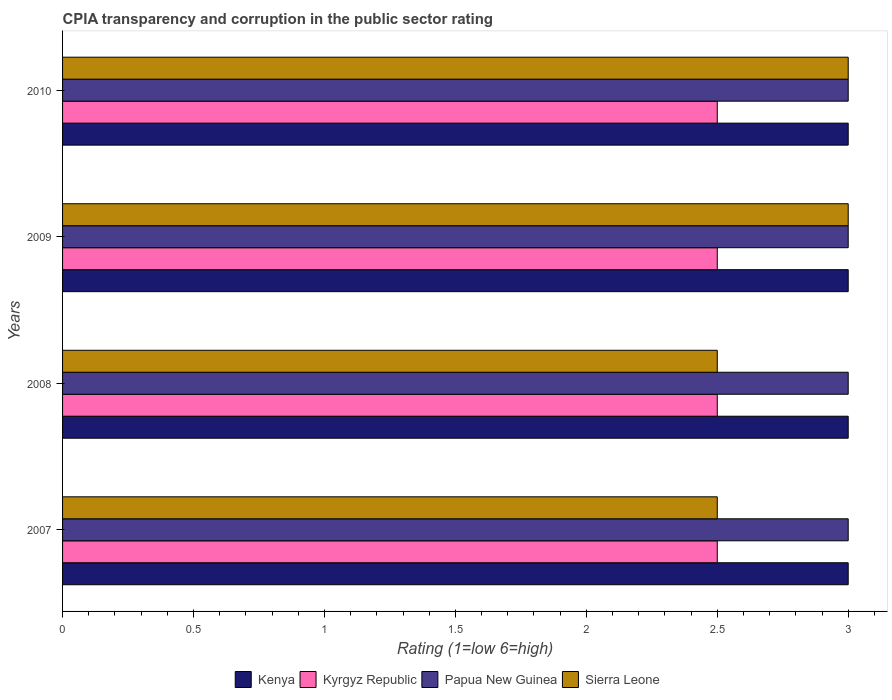Are the number of bars on each tick of the Y-axis equal?
Your response must be concise. Yes. How many bars are there on the 3rd tick from the top?
Ensure brevity in your answer.  4. How many bars are there on the 4th tick from the bottom?
Provide a short and direct response. 4. What is the CPIA rating in Kyrgyz Republic in 2008?
Keep it short and to the point. 2.5. Across all years, what is the maximum CPIA rating in Kenya?
Your response must be concise. 3. Across all years, what is the minimum CPIA rating in Papua New Guinea?
Offer a terse response. 3. In which year was the CPIA rating in Sierra Leone maximum?
Your response must be concise. 2009. In which year was the CPIA rating in Sierra Leone minimum?
Offer a very short reply. 2007. What is the difference between the CPIA rating in Sierra Leone in 2007 and that in 2010?
Provide a succinct answer. -0.5. Is the difference between the CPIA rating in Kenya in 2008 and 2010 greater than the difference between the CPIA rating in Kyrgyz Republic in 2008 and 2010?
Your answer should be very brief. No. What is the difference between the highest and the second highest CPIA rating in Kenya?
Give a very brief answer. 0. What does the 3rd bar from the top in 2009 represents?
Provide a short and direct response. Kyrgyz Republic. What does the 4th bar from the bottom in 2007 represents?
Give a very brief answer. Sierra Leone. How many bars are there?
Your answer should be compact. 16. What is the difference between two consecutive major ticks on the X-axis?
Give a very brief answer. 0.5. Does the graph contain any zero values?
Ensure brevity in your answer.  No. Where does the legend appear in the graph?
Ensure brevity in your answer.  Bottom center. How many legend labels are there?
Make the answer very short. 4. What is the title of the graph?
Your response must be concise. CPIA transparency and corruption in the public sector rating. Does "Ghana" appear as one of the legend labels in the graph?
Provide a succinct answer. No. What is the label or title of the Y-axis?
Your answer should be very brief. Years. What is the Rating (1=low 6=high) of Kenya in 2007?
Keep it short and to the point. 3. What is the Rating (1=low 6=high) in Papua New Guinea in 2007?
Give a very brief answer. 3. What is the Rating (1=low 6=high) in Kenya in 2008?
Give a very brief answer. 3. What is the Rating (1=low 6=high) in Sierra Leone in 2008?
Give a very brief answer. 2.5. What is the Rating (1=low 6=high) of Kyrgyz Republic in 2009?
Offer a terse response. 2.5. What is the Rating (1=low 6=high) of Papua New Guinea in 2009?
Keep it short and to the point. 3. What is the Rating (1=low 6=high) in Kenya in 2010?
Your response must be concise. 3. What is the Rating (1=low 6=high) of Kyrgyz Republic in 2010?
Ensure brevity in your answer.  2.5. What is the Rating (1=low 6=high) of Papua New Guinea in 2010?
Your response must be concise. 3. Across all years, what is the maximum Rating (1=low 6=high) of Papua New Guinea?
Offer a terse response. 3. Across all years, what is the maximum Rating (1=low 6=high) in Sierra Leone?
Make the answer very short. 3. Across all years, what is the minimum Rating (1=low 6=high) in Papua New Guinea?
Your answer should be very brief. 3. Across all years, what is the minimum Rating (1=low 6=high) of Sierra Leone?
Offer a terse response. 2.5. What is the total Rating (1=low 6=high) in Kenya in the graph?
Your answer should be very brief. 12. What is the total Rating (1=low 6=high) in Sierra Leone in the graph?
Offer a very short reply. 11. What is the difference between the Rating (1=low 6=high) of Kyrgyz Republic in 2007 and that in 2008?
Ensure brevity in your answer.  0. What is the difference between the Rating (1=low 6=high) in Papua New Guinea in 2007 and that in 2008?
Offer a terse response. 0. What is the difference between the Rating (1=low 6=high) of Sierra Leone in 2007 and that in 2008?
Your answer should be compact. 0. What is the difference between the Rating (1=low 6=high) of Kyrgyz Republic in 2007 and that in 2009?
Provide a short and direct response. 0. What is the difference between the Rating (1=low 6=high) in Kenya in 2007 and that in 2010?
Provide a short and direct response. 0. What is the difference between the Rating (1=low 6=high) of Papua New Guinea in 2007 and that in 2010?
Ensure brevity in your answer.  0. What is the difference between the Rating (1=low 6=high) of Sierra Leone in 2007 and that in 2010?
Make the answer very short. -0.5. What is the difference between the Rating (1=low 6=high) of Kenya in 2008 and that in 2009?
Give a very brief answer. 0. What is the difference between the Rating (1=low 6=high) of Papua New Guinea in 2008 and that in 2009?
Your answer should be compact. 0. What is the difference between the Rating (1=low 6=high) of Sierra Leone in 2008 and that in 2009?
Offer a terse response. -0.5. What is the difference between the Rating (1=low 6=high) in Kenya in 2009 and that in 2010?
Provide a succinct answer. 0. What is the difference between the Rating (1=low 6=high) of Papua New Guinea in 2009 and that in 2010?
Provide a short and direct response. 0. What is the difference between the Rating (1=low 6=high) of Sierra Leone in 2009 and that in 2010?
Your response must be concise. 0. What is the difference between the Rating (1=low 6=high) of Kenya in 2007 and the Rating (1=low 6=high) of Papua New Guinea in 2008?
Offer a terse response. 0. What is the difference between the Rating (1=low 6=high) of Kenya in 2007 and the Rating (1=low 6=high) of Sierra Leone in 2008?
Offer a terse response. 0.5. What is the difference between the Rating (1=low 6=high) in Kyrgyz Republic in 2007 and the Rating (1=low 6=high) in Sierra Leone in 2008?
Offer a very short reply. 0. What is the difference between the Rating (1=low 6=high) of Papua New Guinea in 2007 and the Rating (1=low 6=high) of Sierra Leone in 2008?
Your response must be concise. 0.5. What is the difference between the Rating (1=low 6=high) in Kenya in 2007 and the Rating (1=low 6=high) in Kyrgyz Republic in 2009?
Your answer should be very brief. 0.5. What is the difference between the Rating (1=low 6=high) in Kenya in 2007 and the Rating (1=low 6=high) in Papua New Guinea in 2009?
Your response must be concise. 0. What is the difference between the Rating (1=low 6=high) in Kenya in 2007 and the Rating (1=low 6=high) in Sierra Leone in 2009?
Give a very brief answer. 0. What is the difference between the Rating (1=low 6=high) in Kyrgyz Republic in 2007 and the Rating (1=low 6=high) in Papua New Guinea in 2009?
Give a very brief answer. -0.5. What is the difference between the Rating (1=low 6=high) in Kyrgyz Republic in 2007 and the Rating (1=low 6=high) in Sierra Leone in 2009?
Ensure brevity in your answer.  -0.5. What is the difference between the Rating (1=low 6=high) of Kenya in 2007 and the Rating (1=low 6=high) of Kyrgyz Republic in 2010?
Provide a short and direct response. 0.5. What is the difference between the Rating (1=low 6=high) of Kenya in 2007 and the Rating (1=low 6=high) of Sierra Leone in 2010?
Your answer should be compact. 0. What is the difference between the Rating (1=low 6=high) in Papua New Guinea in 2007 and the Rating (1=low 6=high) in Sierra Leone in 2010?
Ensure brevity in your answer.  0. What is the difference between the Rating (1=low 6=high) in Kenya in 2008 and the Rating (1=low 6=high) in Kyrgyz Republic in 2009?
Give a very brief answer. 0.5. What is the difference between the Rating (1=low 6=high) of Kenya in 2008 and the Rating (1=low 6=high) of Papua New Guinea in 2009?
Ensure brevity in your answer.  0. What is the difference between the Rating (1=low 6=high) of Kyrgyz Republic in 2008 and the Rating (1=low 6=high) of Papua New Guinea in 2009?
Keep it short and to the point. -0.5. What is the difference between the Rating (1=low 6=high) in Kyrgyz Republic in 2008 and the Rating (1=low 6=high) in Sierra Leone in 2009?
Your answer should be very brief. -0.5. What is the difference between the Rating (1=low 6=high) in Papua New Guinea in 2008 and the Rating (1=low 6=high) in Sierra Leone in 2009?
Provide a succinct answer. 0. What is the difference between the Rating (1=low 6=high) in Kenya in 2008 and the Rating (1=low 6=high) in Kyrgyz Republic in 2010?
Your answer should be compact. 0.5. What is the difference between the Rating (1=low 6=high) in Kenya in 2008 and the Rating (1=low 6=high) in Papua New Guinea in 2010?
Offer a very short reply. 0. What is the difference between the Rating (1=low 6=high) of Papua New Guinea in 2008 and the Rating (1=low 6=high) of Sierra Leone in 2010?
Ensure brevity in your answer.  0. What is the difference between the Rating (1=low 6=high) in Kyrgyz Republic in 2009 and the Rating (1=low 6=high) in Papua New Guinea in 2010?
Your answer should be compact. -0.5. What is the difference between the Rating (1=low 6=high) in Papua New Guinea in 2009 and the Rating (1=low 6=high) in Sierra Leone in 2010?
Your answer should be compact. 0. What is the average Rating (1=low 6=high) in Kenya per year?
Provide a succinct answer. 3. What is the average Rating (1=low 6=high) of Sierra Leone per year?
Ensure brevity in your answer.  2.75. In the year 2007, what is the difference between the Rating (1=low 6=high) in Kenya and Rating (1=low 6=high) in Sierra Leone?
Make the answer very short. 0.5. In the year 2007, what is the difference between the Rating (1=low 6=high) in Kyrgyz Republic and Rating (1=low 6=high) in Papua New Guinea?
Give a very brief answer. -0.5. In the year 2007, what is the difference between the Rating (1=low 6=high) in Kyrgyz Republic and Rating (1=low 6=high) in Sierra Leone?
Your answer should be compact. 0. In the year 2008, what is the difference between the Rating (1=low 6=high) of Kenya and Rating (1=low 6=high) of Papua New Guinea?
Offer a very short reply. 0. In the year 2008, what is the difference between the Rating (1=low 6=high) of Kenya and Rating (1=low 6=high) of Sierra Leone?
Provide a short and direct response. 0.5. In the year 2008, what is the difference between the Rating (1=low 6=high) of Kyrgyz Republic and Rating (1=low 6=high) of Papua New Guinea?
Offer a terse response. -0.5. In the year 2008, what is the difference between the Rating (1=low 6=high) of Papua New Guinea and Rating (1=low 6=high) of Sierra Leone?
Give a very brief answer. 0.5. In the year 2009, what is the difference between the Rating (1=low 6=high) in Kenya and Rating (1=low 6=high) in Kyrgyz Republic?
Provide a short and direct response. 0.5. In the year 2009, what is the difference between the Rating (1=low 6=high) in Kyrgyz Republic and Rating (1=low 6=high) in Sierra Leone?
Offer a terse response. -0.5. In the year 2009, what is the difference between the Rating (1=low 6=high) in Papua New Guinea and Rating (1=low 6=high) in Sierra Leone?
Make the answer very short. 0. In the year 2010, what is the difference between the Rating (1=low 6=high) in Kenya and Rating (1=low 6=high) in Kyrgyz Republic?
Keep it short and to the point. 0.5. In the year 2010, what is the difference between the Rating (1=low 6=high) of Kenya and Rating (1=low 6=high) of Papua New Guinea?
Offer a terse response. 0. What is the ratio of the Rating (1=low 6=high) of Sierra Leone in 2007 to that in 2008?
Provide a short and direct response. 1. What is the ratio of the Rating (1=low 6=high) in Kenya in 2007 to that in 2009?
Your answer should be compact. 1. What is the ratio of the Rating (1=low 6=high) of Kyrgyz Republic in 2007 to that in 2009?
Give a very brief answer. 1. What is the ratio of the Rating (1=low 6=high) of Papua New Guinea in 2007 to that in 2009?
Provide a succinct answer. 1. What is the ratio of the Rating (1=low 6=high) of Kyrgyz Republic in 2007 to that in 2010?
Offer a very short reply. 1. What is the ratio of the Rating (1=low 6=high) in Sierra Leone in 2007 to that in 2010?
Your response must be concise. 0.83. What is the ratio of the Rating (1=low 6=high) of Kenya in 2008 to that in 2009?
Your answer should be very brief. 1. What is the ratio of the Rating (1=low 6=high) of Kyrgyz Republic in 2008 to that in 2009?
Provide a succinct answer. 1. What is the ratio of the Rating (1=low 6=high) of Kyrgyz Republic in 2008 to that in 2010?
Your response must be concise. 1. What is the ratio of the Rating (1=low 6=high) of Papua New Guinea in 2008 to that in 2010?
Keep it short and to the point. 1. What is the ratio of the Rating (1=low 6=high) of Kyrgyz Republic in 2009 to that in 2010?
Your answer should be very brief. 1. What is the ratio of the Rating (1=low 6=high) in Sierra Leone in 2009 to that in 2010?
Provide a succinct answer. 1. What is the difference between the highest and the second highest Rating (1=low 6=high) of Kenya?
Provide a short and direct response. 0. What is the difference between the highest and the second highest Rating (1=low 6=high) in Kyrgyz Republic?
Provide a short and direct response. 0. What is the difference between the highest and the second highest Rating (1=low 6=high) of Papua New Guinea?
Provide a succinct answer. 0. What is the difference between the highest and the lowest Rating (1=low 6=high) of Kenya?
Give a very brief answer. 0. What is the difference between the highest and the lowest Rating (1=low 6=high) of Kyrgyz Republic?
Give a very brief answer. 0. What is the difference between the highest and the lowest Rating (1=low 6=high) of Papua New Guinea?
Keep it short and to the point. 0. What is the difference between the highest and the lowest Rating (1=low 6=high) of Sierra Leone?
Your response must be concise. 0.5. 